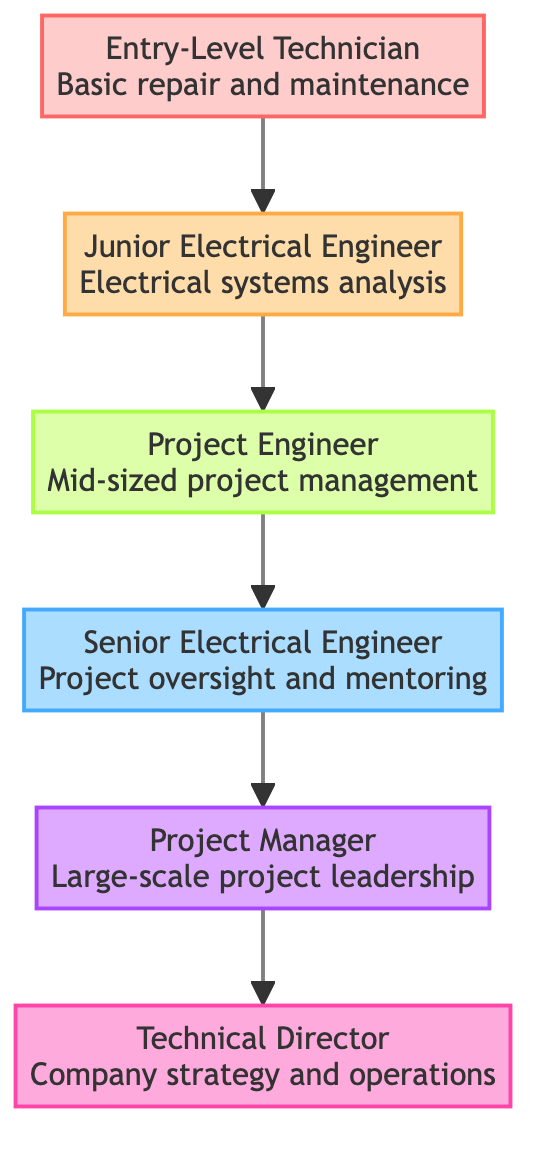What is the topmost level in the career progression at PECO? The highest level in the flow chart is the "Technical Director." This can be found by identifying the node that has no further nodes above it, indicating it is at the peak of the career progression.
Answer: Technical Director How many total career levels are represented in the diagram? By counting each distinct level from "Entry-Level Technician" to "Technical Director," we can see that there are a total of six levels.
Answer: 6 What is the title of the second level in the career progression? The second level is "Junior Electrical Engineer." This can be deduced from following the arrows in the diagram to the second node from the bottom.
Answer: Junior Electrical Engineer Which position directly follows the "Project Engineer"? The position that comes after "Project Engineer" is "Senior Electrical Engineer," which can be identified by following the upward arrow from the "Project Engineer" node.
Answer: Senior Electrical Engineer What is the primary responsibility of a "Project Manager"? The main responsibility of a "Project Manager" is large-scale project leadership, as indicated in the description tied to that node in the diagram.
Answer: Large-scale project leadership What type of skills are gained when transitioning from "Junior Electrical Engineer" to "Project Engineer"? The transition to "Project Engineer" involves enhancing project management skills and technical expertise, as described in the node related to "Project Engineer."
Answer: Project management skills and technical expertise What position requires mentorship of junior engineers? The position that involves mentoring junior engineers is "Senior Electrical Engineer." This role specifically includes oversight and mentoring responsibilities as per the corresponding node.
Answer: Senior Electrical Engineer What level is responsible for company strategy and operations? The "Technical Director" is responsible for overall company strategy and operations, which can be determined by examining the description associated with that specific node.
Answer: Technical Director Which career level is the first step in the progression? The first step in the career progression is the "Entry-Level Technician." This is the lowest node in the diagram and serves as the starting point for the sequence.
Answer: Entry-Level Technician 